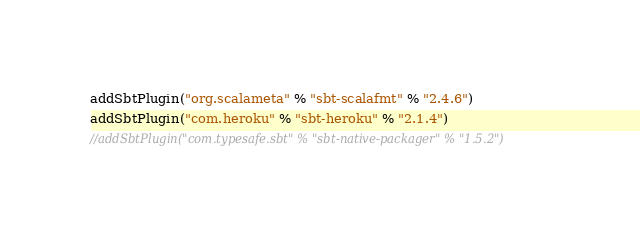Convert code to text. <code><loc_0><loc_0><loc_500><loc_500><_Scala_>
addSbtPlugin("org.scalameta" % "sbt-scalafmt" % "2.4.6")
addSbtPlugin("com.heroku" % "sbt-heroku" % "2.1.4")
//addSbtPlugin("com.typesafe.sbt" % "sbt-native-packager" % "1.5.2")
</code> 